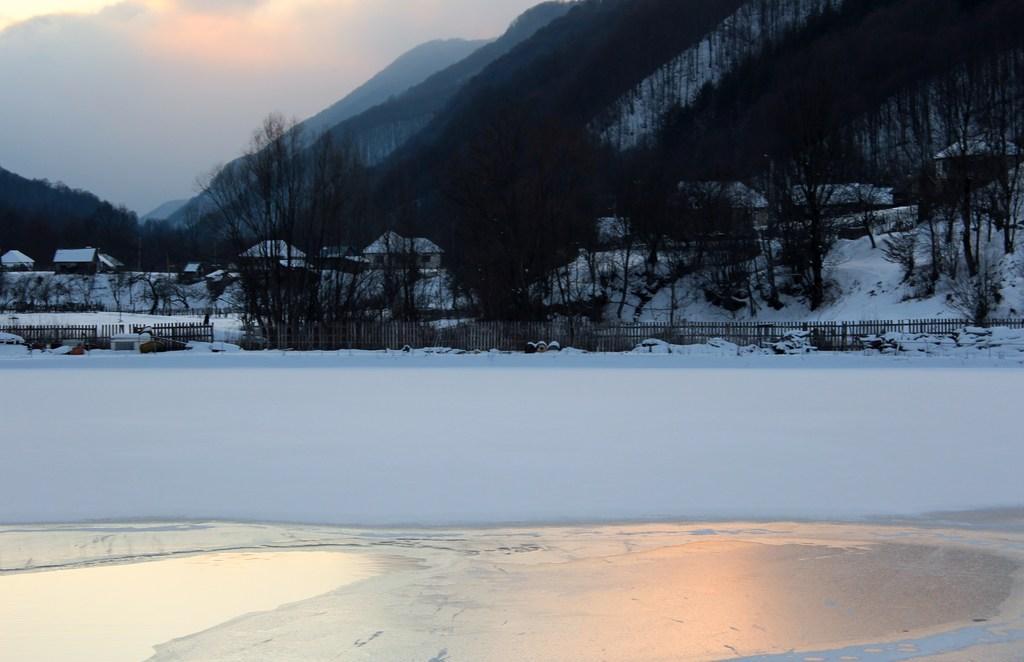Describe this image in one or two sentences. In this image we can see many mountains. There is a snow in the image. There are few houses in the image. There is a fence in the image. There are many trees in the image. 